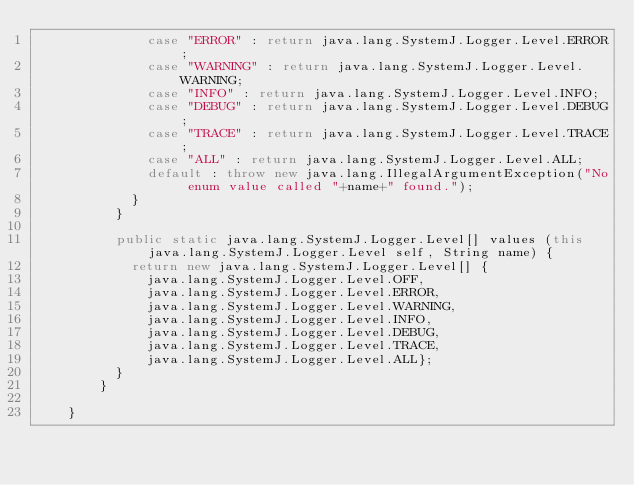<code> <loc_0><loc_0><loc_500><loc_500><_C#_>	          case "ERROR" : return java.lang.SystemJ.Logger.Level.ERROR;
	          case "WARNING" : return java.lang.SystemJ.Logger.Level.WARNING;
	          case "INFO" : return java.lang.SystemJ.Logger.Level.INFO;
	          case "DEBUG" : return java.lang.SystemJ.Logger.Level.DEBUG;
	          case "TRACE" : return java.lang.SystemJ.Logger.Level.TRACE;
	          case "ALL" : return java.lang.SystemJ.Logger.Level.ALL;
	          default : throw new java.lang.IllegalArgumentException("No enum value called "+name+" found.");
	        } 
          }
        
	      public static java.lang.SystemJ.Logger.Level[] values (this java.lang.SystemJ.Logger.Level self, String name) {
	        return new java.lang.SystemJ.Logger.Level[] {
	          java.lang.SystemJ.Logger.Level.OFF,
              java.lang.SystemJ.Logger.Level.ERROR,
	          java.lang.SystemJ.Logger.Level.WARNING,
	          java.lang.SystemJ.Logger.Level.INFO,
	          java.lang.SystemJ.Logger.Level.DEBUG,
	          java.lang.SystemJ.Logger.Level.TRACE,
	          java.lang.SystemJ.Logger.Level.ALL};
          }
        }
      
    }
</code> 